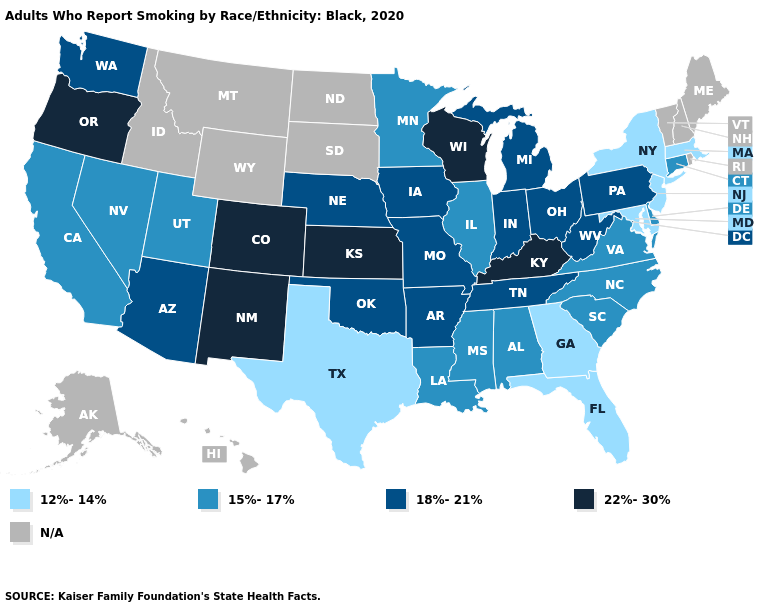What is the highest value in the South ?
Give a very brief answer. 22%-30%. What is the lowest value in states that border New York?
Short answer required. 12%-14%. What is the value of Oregon?
Quick response, please. 22%-30%. Which states hav the highest value in the Northeast?
Short answer required. Pennsylvania. What is the lowest value in the USA?
Be succinct. 12%-14%. What is the value of Wyoming?
Answer briefly. N/A. Name the states that have a value in the range 15%-17%?
Keep it brief. Alabama, California, Connecticut, Delaware, Illinois, Louisiana, Minnesota, Mississippi, Nevada, North Carolina, South Carolina, Utah, Virginia. Name the states that have a value in the range 15%-17%?
Short answer required. Alabama, California, Connecticut, Delaware, Illinois, Louisiana, Minnesota, Mississippi, Nevada, North Carolina, South Carolina, Utah, Virginia. What is the value of Colorado?
Keep it brief. 22%-30%. Which states have the lowest value in the USA?
Give a very brief answer. Florida, Georgia, Maryland, Massachusetts, New Jersey, New York, Texas. What is the value of Minnesota?
Be succinct. 15%-17%. What is the value of Alaska?
Give a very brief answer. N/A. Name the states that have a value in the range 12%-14%?
Quick response, please. Florida, Georgia, Maryland, Massachusetts, New Jersey, New York, Texas. Among the states that border Massachusetts , does New York have the lowest value?
Concise answer only. Yes. 